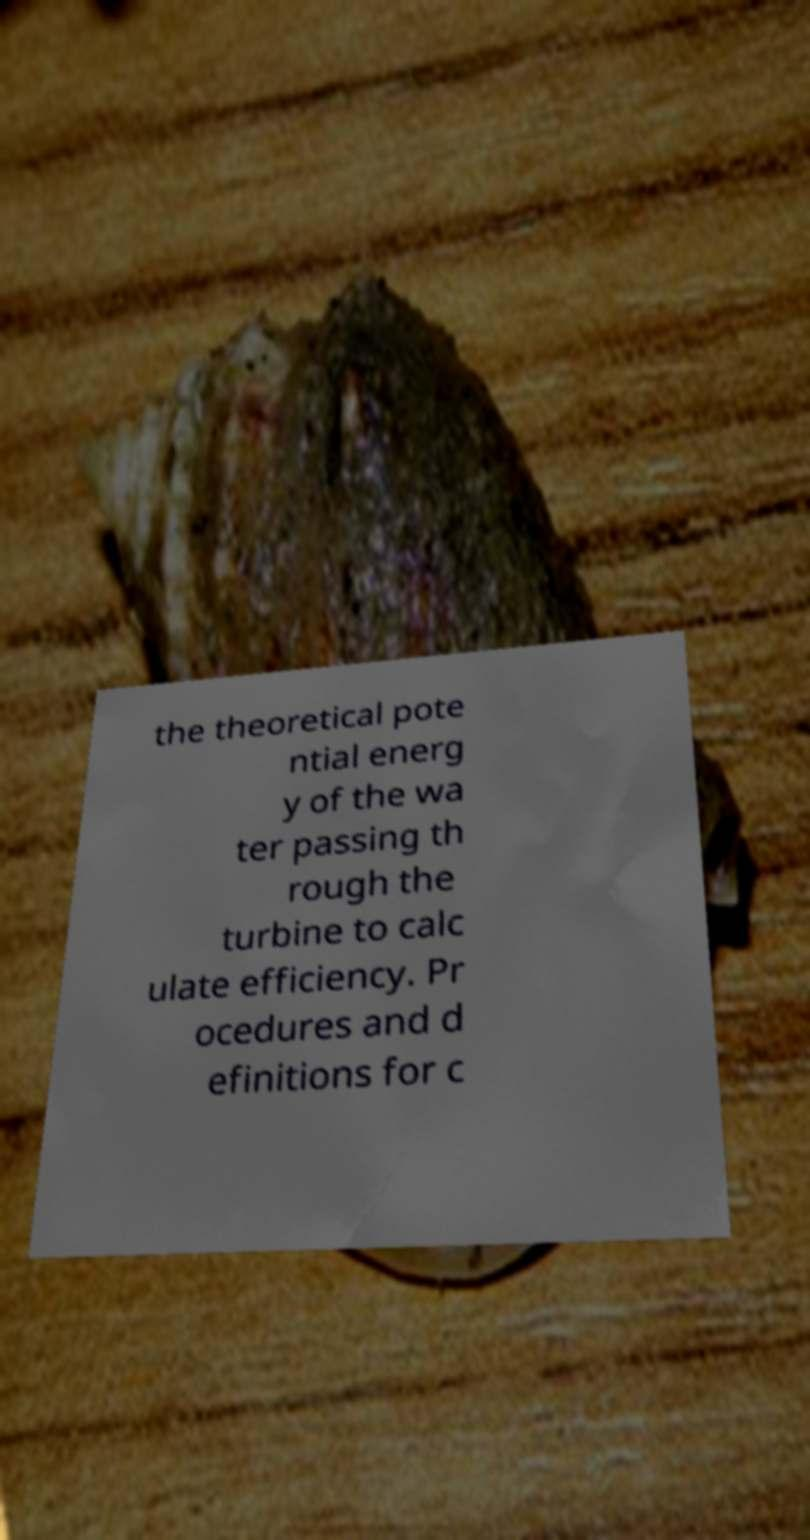Please identify and transcribe the text found in this image. the theoretical pote ntial energ y of the wa ter passing th rough the turbine to calc ulate efficiency. Pr ocedures and d efinitions for c 